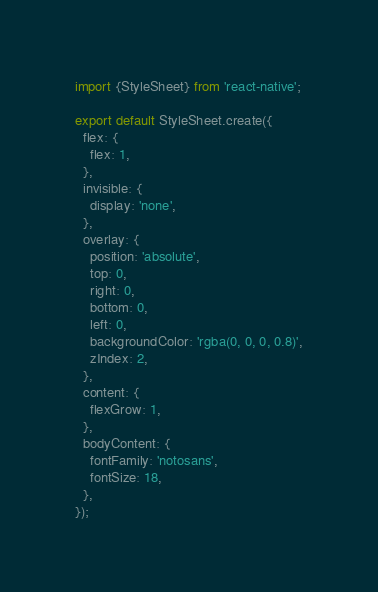Convert code to text. <code><loc_0><loc_0><loc_500><loc_500><_JavaScript_>import {StyleSheet} from 'react-native';

export default StyleSheet.create({
  flex: {
    flex: 1,
  },
  invisible: {
    display: 'none',
  },
  overlay: {
    position: 'absolute',
    top: 0,
    right: 0,
    bottom: 0,
    left: 0,
    backgroundColor: 'rgba(0, 0, 0, 0.8)',
    zIndex: 2,
  },
  content: {
    flexGrow: 1,
  },
  bodyContent: {
    fontFamily: 'notosans',
    fontSize: 18,
  },
});
</code> 